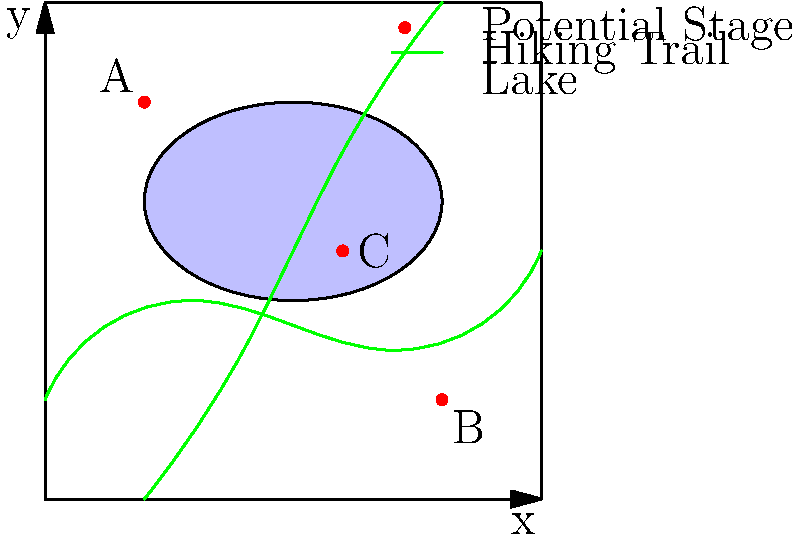A national park has provided you with a map of their grounds for your upcoming outdoor concert. The map uses a coordinate system where each unit represents 10 meters. Three potential stage locations are marked: A(20,80), B(80,20), and C(60,50). You want to choose the location that maximizes the average distance from the stage to the two hiking trails, ensuring minimal disruption to park visitors. Which location should you choose for your stage? To solve this problem, we need to follow these steps:

1) First, we need to find the equations of the two hiking trails. For simplicity, let's approximate them as straight lines:
   Trail 1: $y = 0.3x + 20$
   Trail 2: $y = x$

2) For each potential stage location, we need to calculate its distance to each trail:

   For point A(20,80):
   - Distance to Trail 1: $|80 - (0.3(20) + 20)| / \sqrt{1 + 0.3^2} = 53.85$
   - Distance to Trail 2: $|80 - 20| / \sqrt{2} = 42.43$
   Average distance: $(53.85 + 42.43) / 2 = 48.14$

   For point B(80,20):
   - Distance to Trail 1: $|20 - (0.3(80) + 20)| / \sqrt{1 + 0.3^2} = 3.85$
   - Distance to Trail 2: $|20 - 80| / \sqrt{2} = 42.43$
   Average distance: $(3.85 + 42.43) / 2 = 23.14$

   For point C(60,50):
   - Distance to Trail 1: $|50 - (0.3(60) + 20)| / \sqrt{1 + 0.3^2} = 19.23$
   - Distance to Trail 2: $|50 - 60| / \sqrt{2} = 7.07$
   Average distance: $(19.23 + 7.07) / 2 = 13.15$

3) Compare the average distances:
   A: 48.14
   B: 23.14
   C: 13.15

4) The location with the maximum average distance is A(20,80).
Answer: A(20,80) 